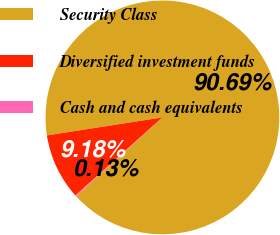Convert chart to OTSL. <chart><loc_0><loc_0><loc_500><loc_500><pie_chart><fcel>Security Class<fcel>Diversified investment funds<fcel>Cash and cash equivalents<nl><fcel>90.69%<fcel>9.18%<fcel>0.13%<nl></chart> 